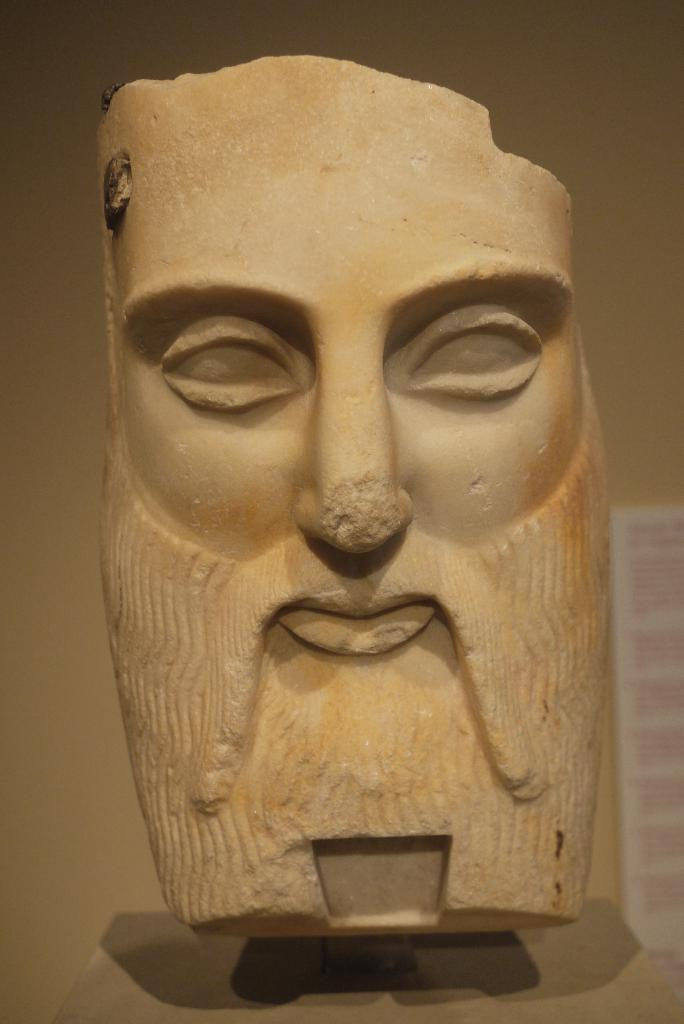What type of object is the main subject of the image? There is a stone carved statue in the image. What can be seen in the background of the image? There is a white wall in the background of the image. What color and design can be observed on the object on the right side of the image? There is a board or banner in white and pink color on the right side of the image. How many crates are stacked next to the statue in the image? There are no crates present in the image. Can you see an ant crawling on the statue in the image? There is no ant visible on the statue in the image. 